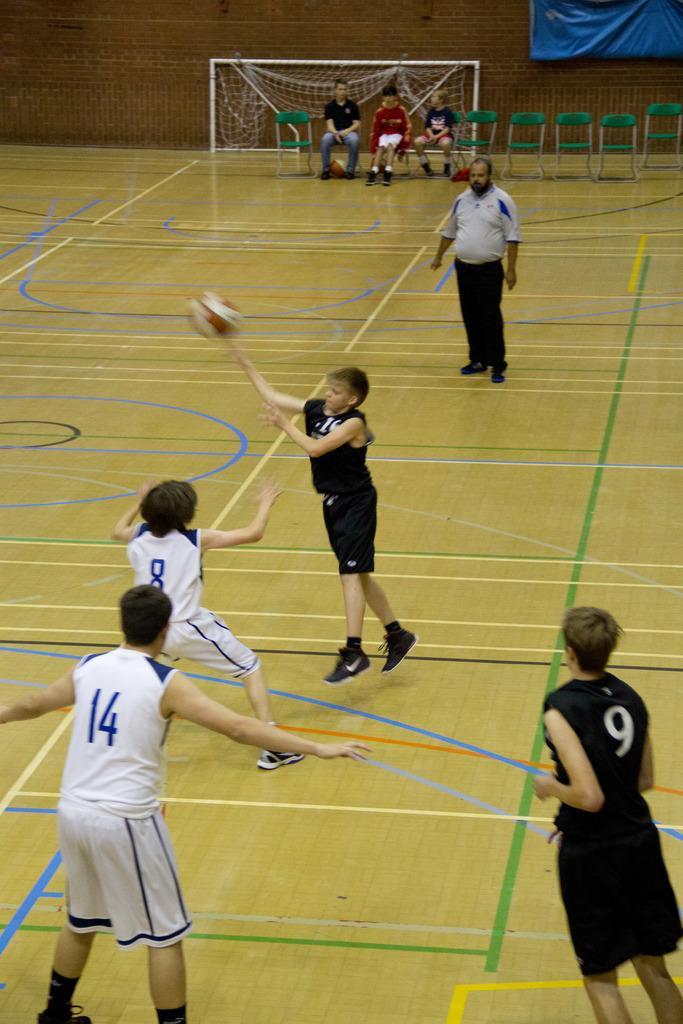Please provide a concise description of this image. In this image we can see a few people, some of them are playing, there are three boys sitting on the chairs, there is a goal post, there is a ball, and a blue colored sheet on the wall. 